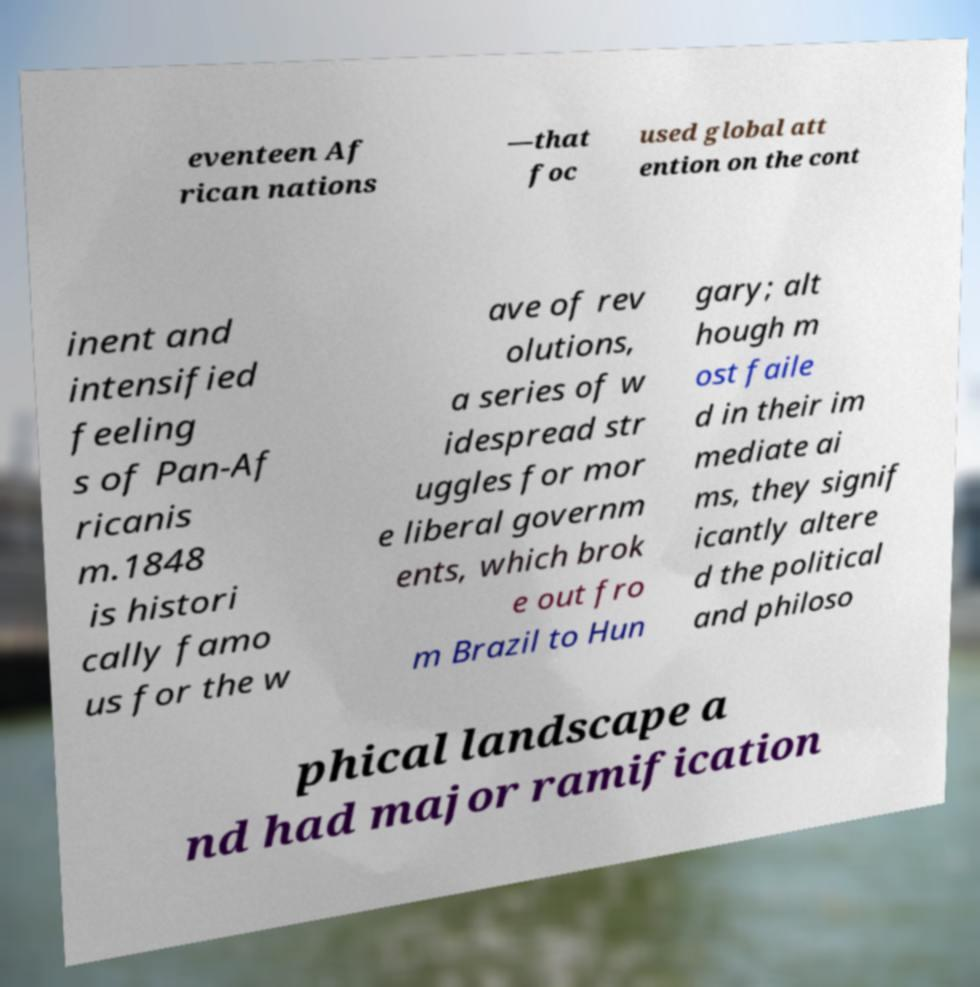What messages or text are displayed in this image? I need them in a readable, typed format. eventeen Af rican nations —that foc used global att ention on the cont inent and intensified feeling s of Pan-Af ricanis m.1848 is histori cally famo us for the w ave of rev olutions, a series of w idespread str uggles for mor e liberal governm ents, which brok e out fro m Brazil to Hun gary; alt hough m ost faile d in their im mediate ai ms, they signif icantly altere d the political and philoso phical landscape a nd had major ramification 